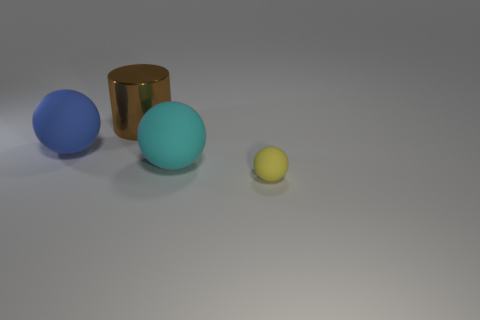Are there any purple rubber cylinders?
Keep it short and to the point. No. Does the small yellow rubber thing have the same shape as the blue thing?
Offer a terse response. Yes. There is a big rubber object that is behind the large sphere that is right of the big metallic object; how many tiny yellow matte balls are left of it?
Make the answer very short. 0. There is a object that is to the right of the blue matte thing and on the left side of the big cyan matte object; what material is it made of?
Provide a succinct answer. Metal. What is the color of the big object that is both in front of the metallic object and on the right side of the big blue rubber thing?
Keep it short and to the point. Cyan. Is there any other thing that is the same color as the metallic cylinder?
Provide a short and direct response. No. The big rubber thing in front of the matte sphere to the left of the big rubber object that is right of the big cylinder is what shape?
Offer a very short reply. Sphere. There is another small matte thing that is the same shape as the cyan object; what is its color?
Offer a very short reply. Yellow. What color is the big rubber sphere to the right of the matte thing on the left side of the large brown object?
Give a very brief answer. Cyan. There is a cyan matte object that is the same shape as the yellow rubber object; what is its size?
Provide a succinct answer. Large. 